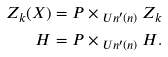Convert formula to latex. <formula><loc_0><loc_0><loc_500><loc_500>Z _ { k } ( X ) & = P \times _ { \ U n ^ { \prime } ( n ) } Z _ { k } \\ H & = P \times _ { \ U n ^ { \prime } ( n ) } H .</formula> 